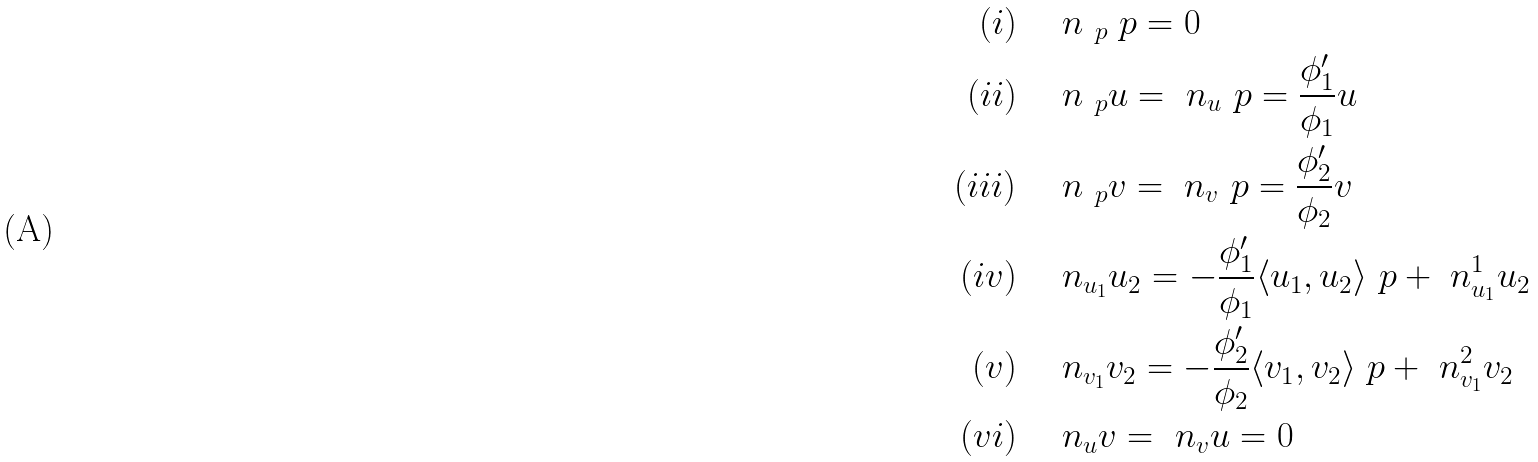Convert formula to latex. <formula><loc_0><loc_0><loc_500><loc_500>( i ) & \quad \ n _ { \ p } \ p = 0 \\ ( i i ) & \quad \ n _ { \ p } u = \ n _ { u } \ p = \frac { \phi _ { 1 } ^ { \prime } } { \phi _ { 1 } } u \\ ( i i i ) & \quad \ n _ { \ p } v = \ n _ { v } \ p = \frac { \phi _ { 2 } ^ { \prime } } { \phi _ { 2 } } v \\ ( i v ) & \quad \ n _ { u _ { 1 } } u _ { 2 } = - \frac { \phi _ { 1 } ^ { \prime } } { \phi _ { 1 } } \langle u _ { 1 } , u _ { 2 } \rangle \ p + \ n ^ { 1 } _ { u _ { 1 } } u _ { 2 } \\ ( v ) & \quad \ n _ { v _ { 1 } } v _ { 2 } = - \frac { \phi _ { 2 } ^ { \prime } } { \phi _ { 2 } } \langle v _ { 1 } , v _ { 2 } \rangle \ p + \ n ^ { 2 } _ { v _ { 1 } } v _ { 2 } \\ ( v i ) & \quad \ n _ { u } v = \ n _ { v } u = 0</formula> 